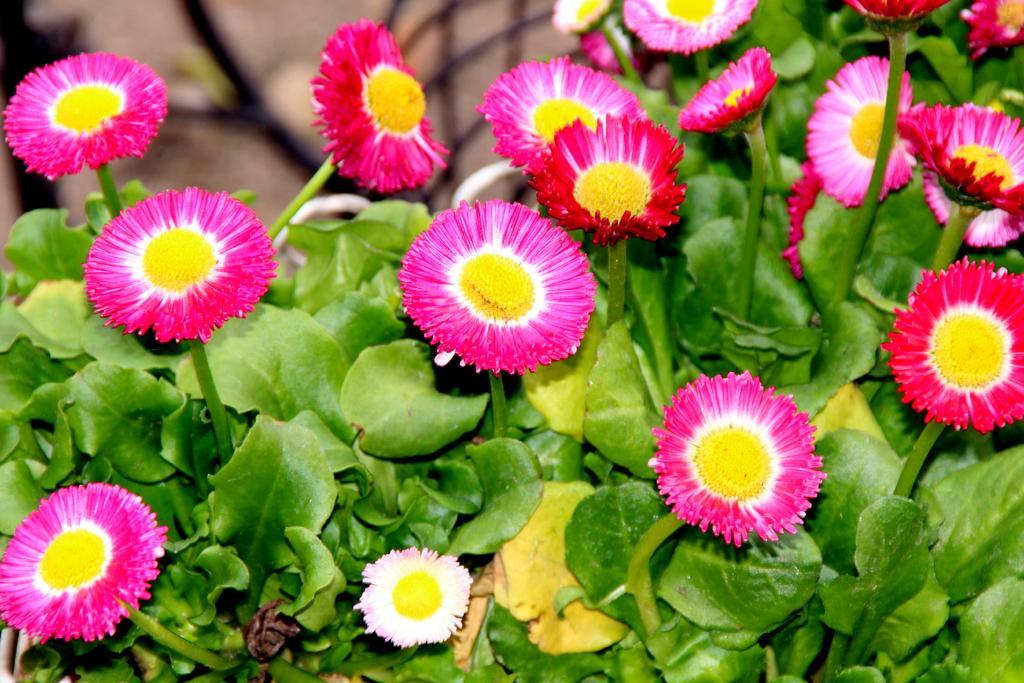Can you describe this image briefly? In this image there are flowers and leaves. 